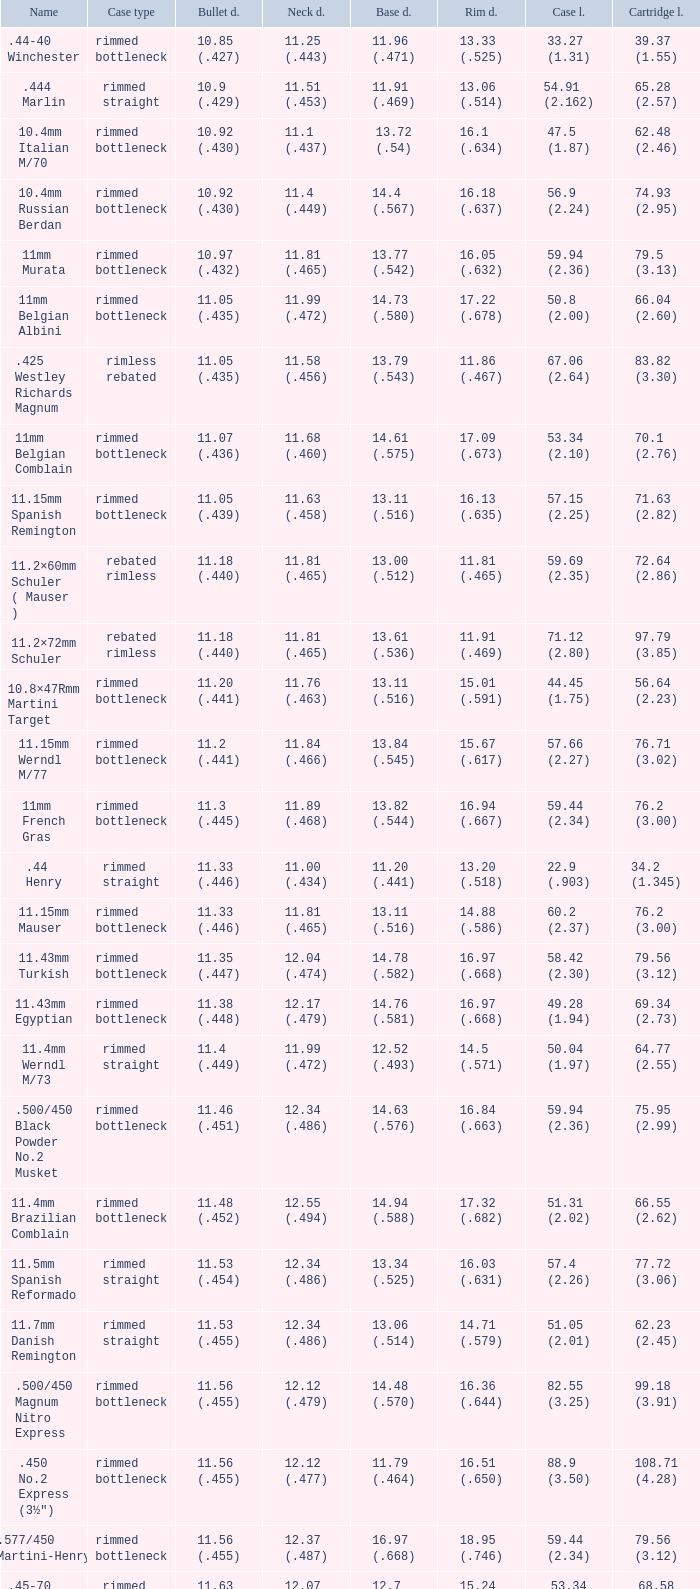Which Rim diameter has a Neck diameter of 11.84 (.466)? 15.67 (.617). 